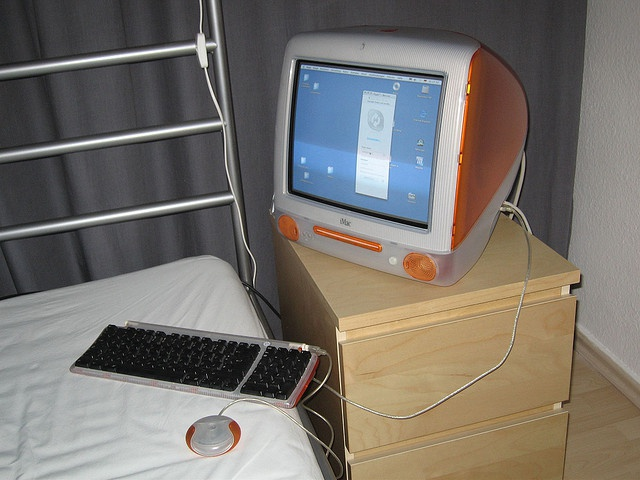Describe the objects in this image and their specific colors. I can see tv in black, darkgray, gray, and lightgray tones, bed in black, darkgray, lightgray, and gray tones, keyboard in black, darkgray, and gray tones, and mouse in black, darkgray, brown, gray, and lightgray tones in this image. 